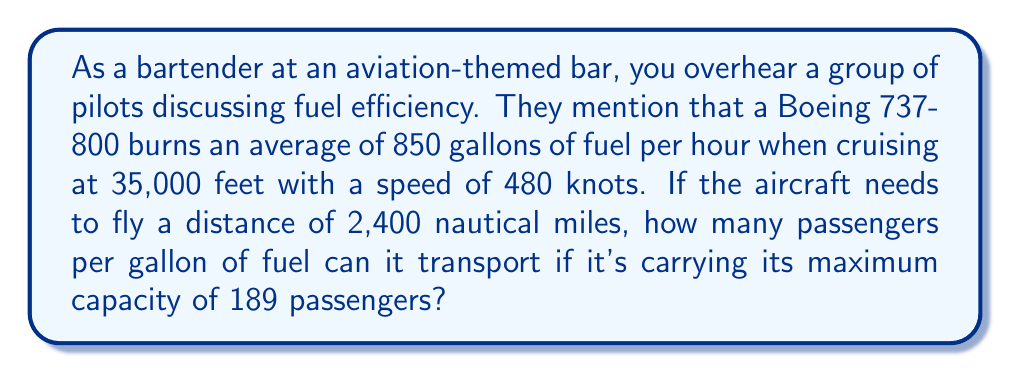Could you help me with this problem? To solve this problem, we need to follow these steps:

1. Calculate the time of the flight:
   $$ \text{Time} = \frac{\text{Distance}}{\text{Speed}} $$
   $$ \text{Time} = \frac{2,400 \text{ nautical miles}}{480 \text{ knots}} = 5 \text{ hours} $$

2. Calculate the total fuel consumed during the flight:
   $$ \text{Fuel consumed} = \text{Fuel burn rate} \times \text{Time} $$
   $$ \text{Fuel consumed} = 850 \text{ gallons/hour} \times 5 \text{ hours} = 4,250 \text{ gallons} $$

3. Calculate the number of passengers per gallon:
   $$ \text{Passengers per gallon} = \frac{\text{Number of passengers}}{\text{Total fuel consumed}} $$
   $$ \text{Passengers per gallon} = \frac{189 \text{ passengers}}{4,250 \text{ gallons}} $$
   $$ \text{Passengers per gallon} = 0.0444706 \text{ passengers/gallon} $$

4. Round to 4 decimal places:
   $$ \text{Passengers per gallon} \approx 0.0445 \text{ passengers/gallon} $$
Answer: The Boeing 737-800 can transport approximately 0.0445 passengers per gallon of fuel for the given flight conditions. 